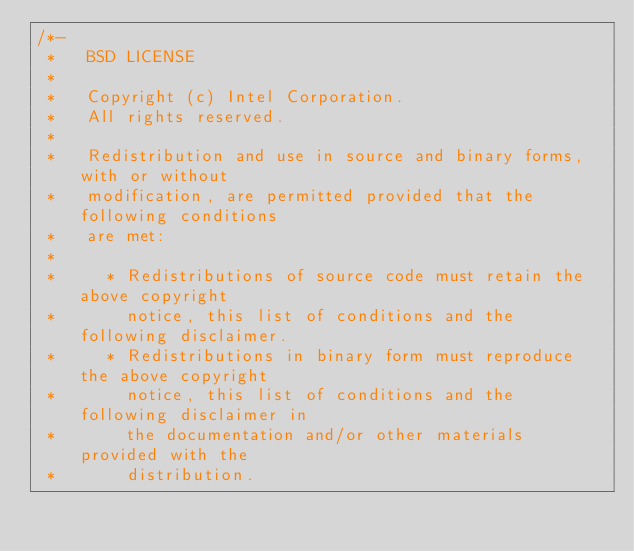<code> <loc_0><loc_0><loc_500><loc_500><_C_>/*-
 *   BSD LICENSE
 *
 *   Copyright (c) Intel Corporation.
 *   All rights reserved.
 *
 *   Redistribution and use in source and binary forms, with or without
 *   modification, are permitted provided that the following conditions
 *   are met:
 *
 *     * Redistributions of source code must retain the above copyright
 *       notice, this list of conditions and the following disclaimer.
 *     * Redistributions in binary form must reproduce the above copyright
 *       notice, this list of conditions and the following disclaimer in
 *       the documentation and/or other materials provided with the
 *       distribution.</code> 